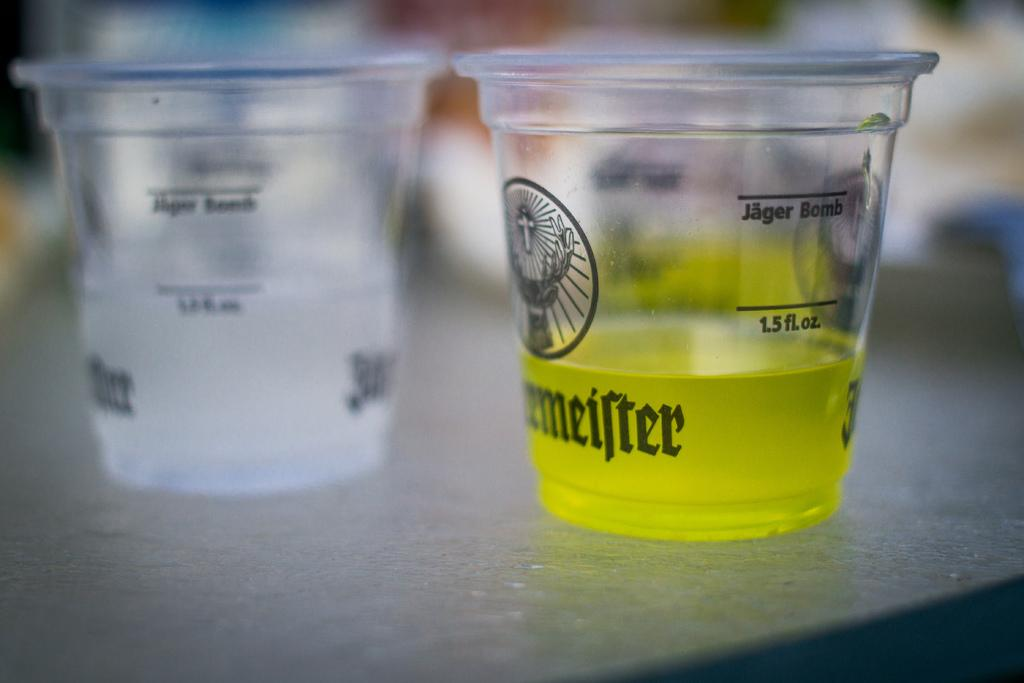<image>
Offer a succinct explanation of the picture presented. Two small plastic cups wit hone having the measurement for 1.5 oz on it with green liquid. 